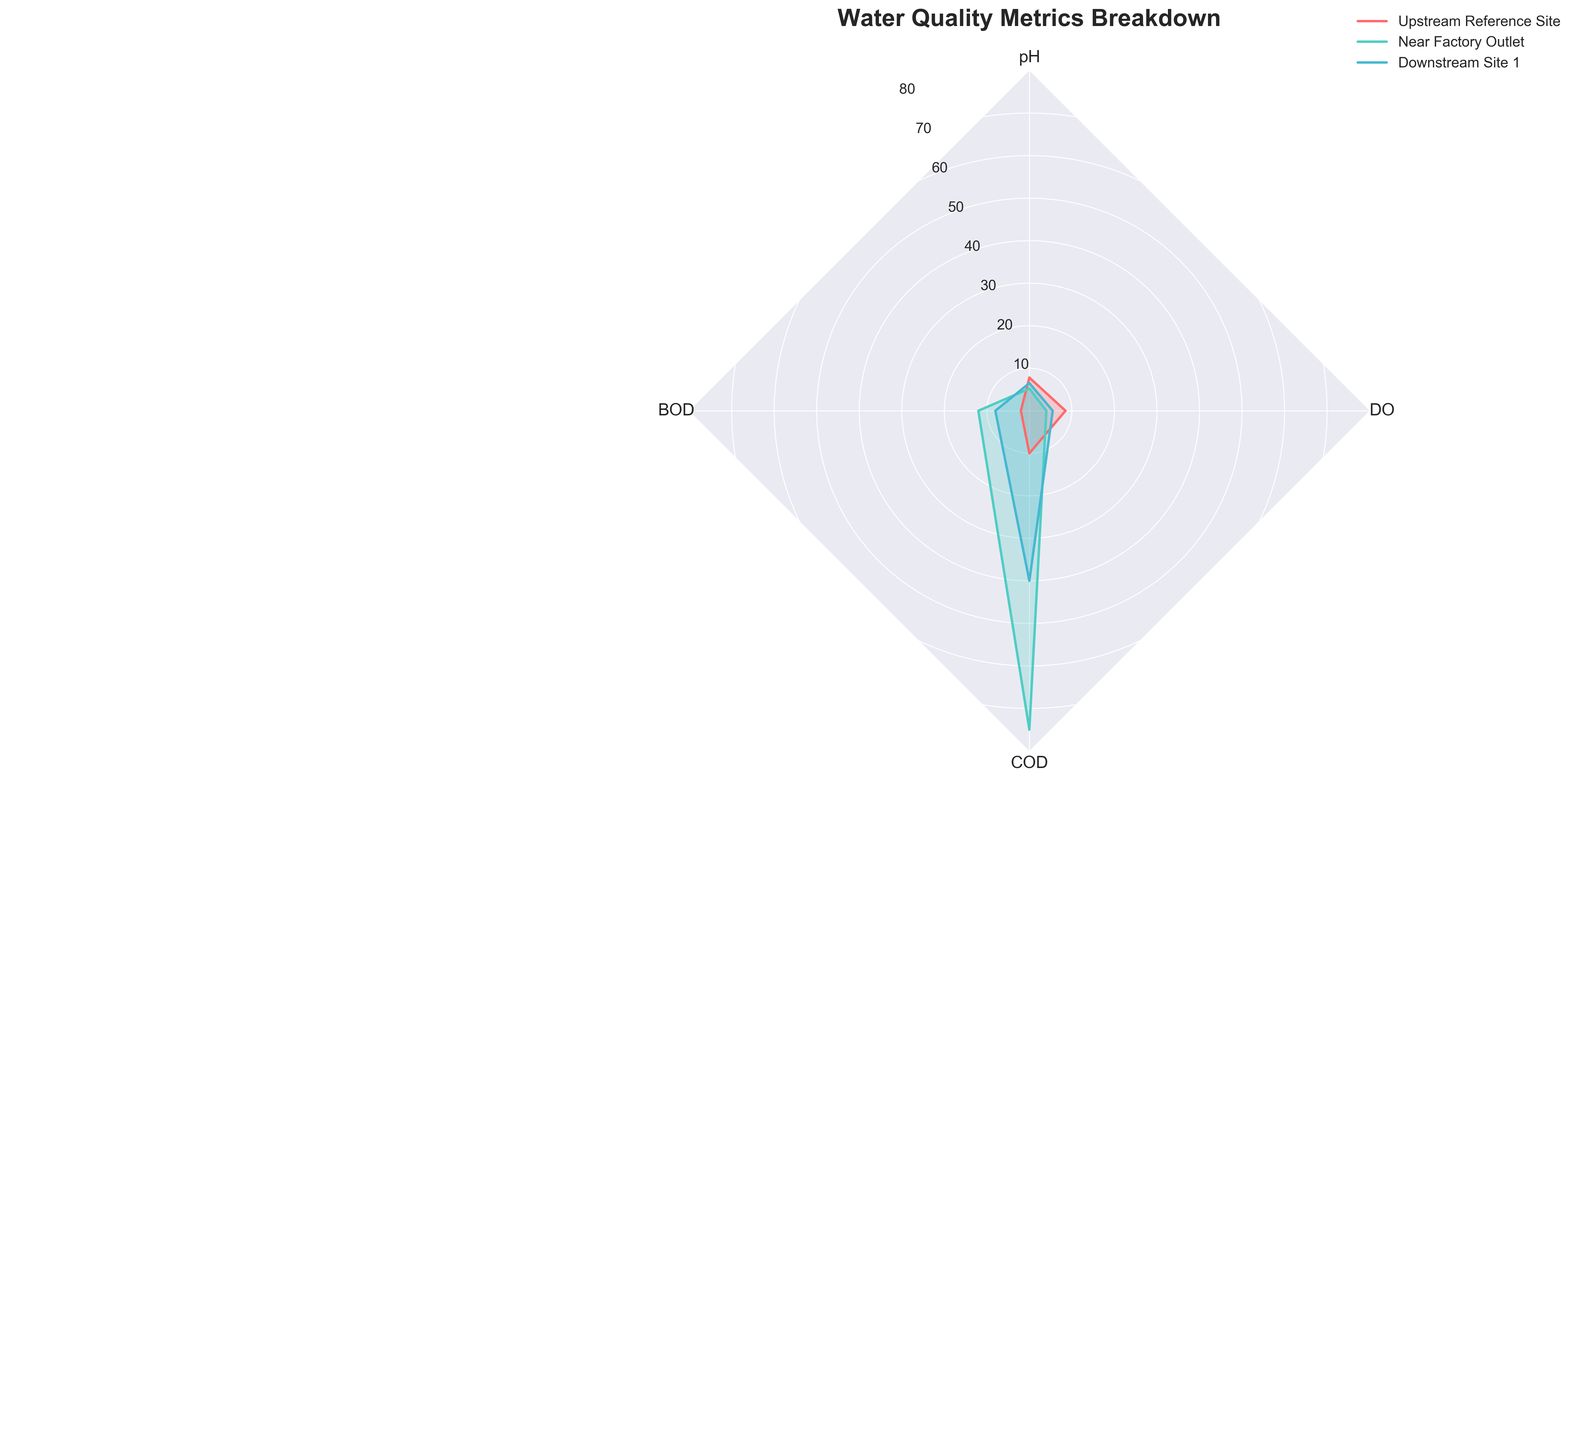What are the four water quality metrics displayed in the figure? The radar chart has axes labeled with the four water quality metrics being analyzed. By examining the labels on the axes, you can identify them as pH, BOD, COD, and DO.
Answer: pH, BOD, COD, DO Can you list the groups compared in the radar chart? By reading the legend on the radar chart, we see the groups represented by different colors. They are "Upstream Reference Site", "Near Factory Outlet", and "Downstream Site 1".
Answer: Upstream Reference Site, Near Factory Outlet, Downstream Site 1 Which group has the highest BOD level? Locate the BOD axis and check the values for each group. "Near Factory Outlet" has the highest value, depicted by the fullest extension along the BOD axis.
Answer: Near Factory Outlet How does the pH value near the factory outlet compare to the upstream reference site? By comparing the length along the pH axis for both groups, the pH near the factory outlet is significantly lower than that at the upstream reference site.
Answer: Lower What is the range of DO values across the groups? Examine the extent of values along the DO axis for each group. The upstream reference site has a DO value around 8.5, near the factory outlet has approximately 4.0, and downstream site 1 has around 5.5. Therefore, the range is 4.0 to 8.5.
Answer: 4.0 to 8.5 Which group has the most balanced water quality metrics? Assess the radar chart for the group whose values are more evenly distributed across all metrics. The "Upstream Reference Site" has relatively balanced values, with all metrics showing moderate levels compared to the other groups.
Answer: Upstream Reference Site What is the difference in COD levels between the upstream reference site and near the factory outlet? Check the COD axis for both groups. The upstream reference site has a value of 10.0, and near the factory outlet has 75.0. The difference is 75.0 - 10.0 = 65.0.
Answer: 65.0 In which group does the DO level fall below 6? Examine the values along the DO axis and observe that both "Near Factory Outlet" and "Downstream Site 1" have DO levels below 6.
Answer: Near Factory Outlet, Downstream Site 1 What are the implications of the difference in pH levels between the "Upstream Reference Site" and "Near Factory Outlet"? The "Upstream Reference Site" has a pH of 7.8, indicating relatively neutral water, while the "Near Factory Outlet" has a pH of 5.2, indicating more acidic water. This acidification near the factory outlet suggests potential chemical discharge affecting water quality.
Answer: Potential chemical discharge affecting water quality near the factory outlet Based on the chart, which metric indicates the most significant disparity among different groups? Observing the radar chart, the BOD and COD metrics show the most significant variations between groups, with the 'Near Factory Outlet' having much higher values than others. However, among them, COD shows the biggest disparity.
Answer: COD 